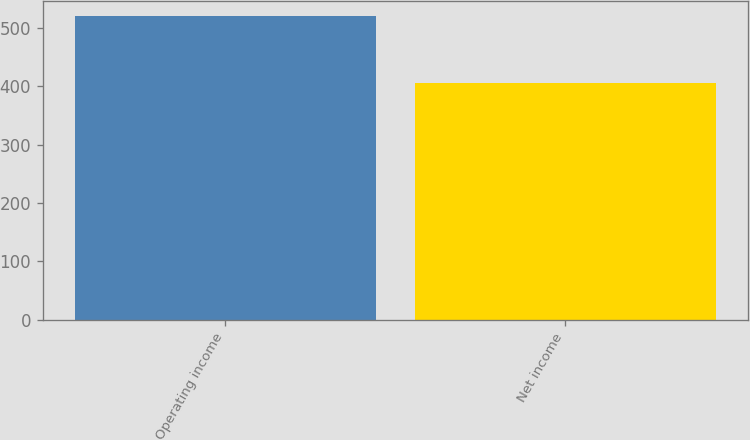<chart> <loc_0><loc_0><loc_500><loc_500><bar_chart><fcel>Operating income<fcel>Net income<nl><fcel>521<fcel>405<nl></chart> 